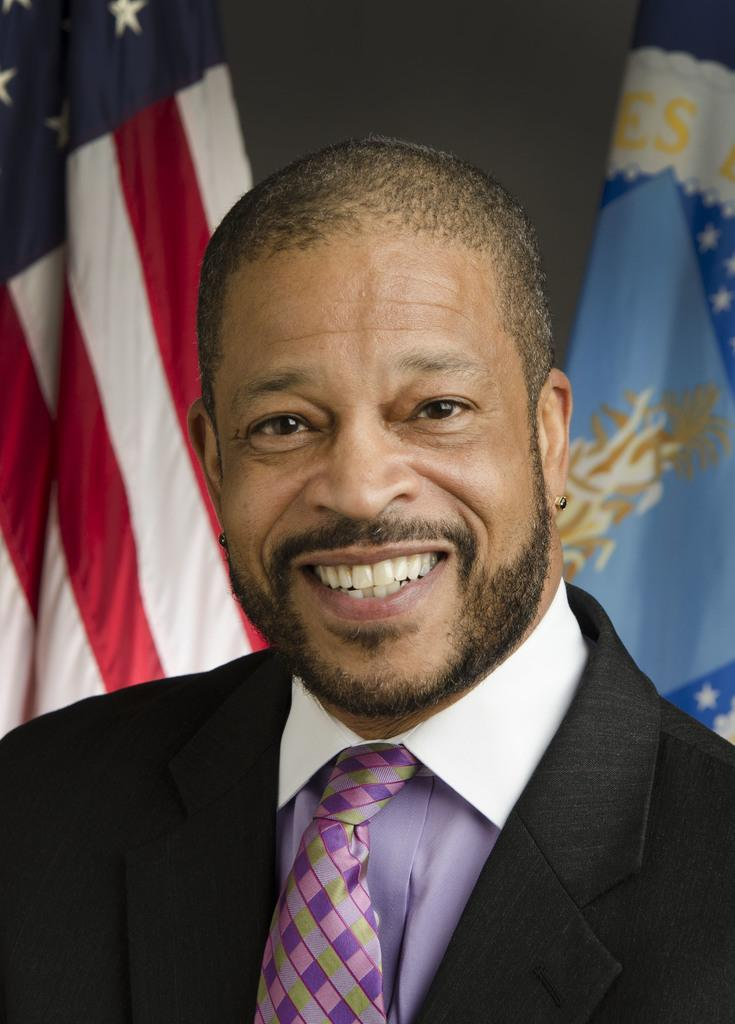Who or what is the main subject in the image? There is a person in the image. Can you describe the person's attire? The person is wearing a white shirt, a tie, and a black blazer. What can be seen in the background of the image? There are two flags in the background of the image. What type of soap is being used in the operation depicted in the image? There is no operation or soap present in the image; it features a person wearing a white shirt, a tie, and a black blazer, with two flags in the background. 